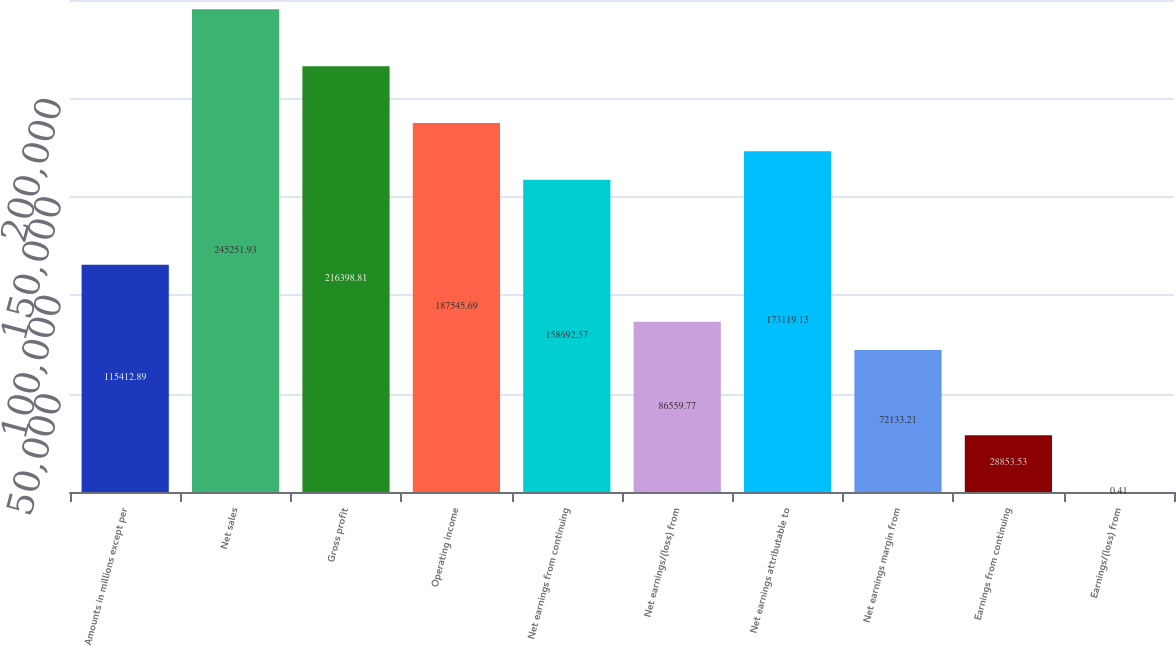Convert chart. <chart><loc_0><loc_0><loc_500><loc_500><bar_chart><fcel>Amounts in millions except per<fcel>Net sales<fcel>Gross profit<fcel>Operating income<fcel>Net earnings from continuing<fcel>Net earnings/(loss) from<fcel>Net earnings attributable to<fcel>Net earnings margin from<fcel>Earnings from continuing<fcel>Earnings/(loss) from<nl><fcel>115413<fcel>245252<fcel>216399<fcel>187546<fcel>158693<fcel>86559.8<fcel>173119<fcel>72133.2<fcel>28853.5<fcel>0.41<nl></chart> 